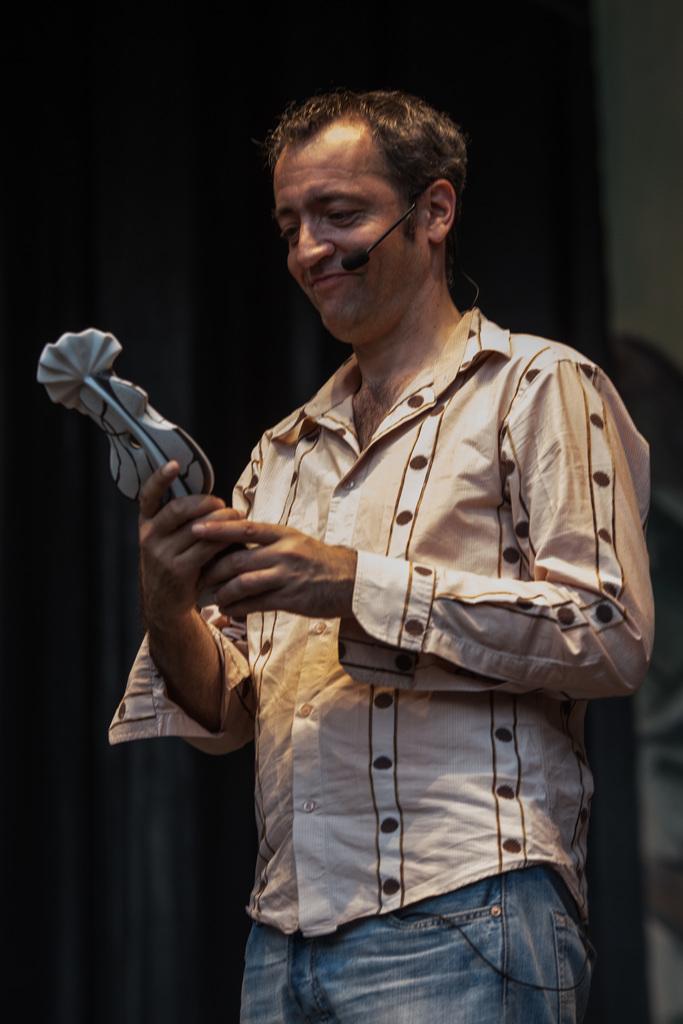Could you give a brief overview of what you see in this image? Here in this picture we can see a person standing over a place and he is holding something in his hands and we can see microphone present on his ear and he is smiling. 